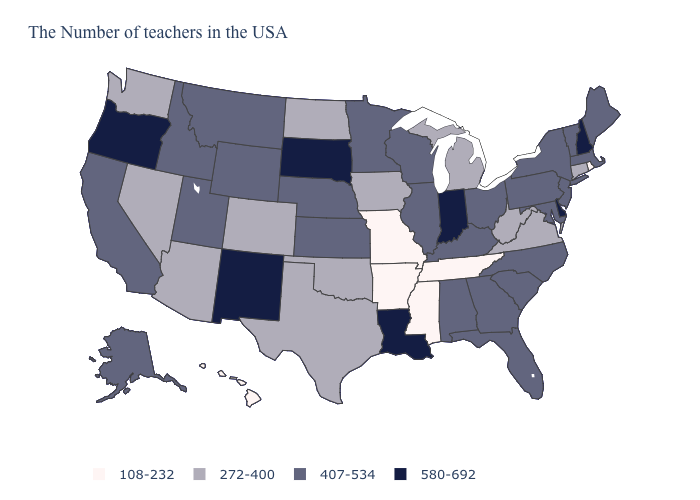Name the states that have a value in the range 272-400?
Quick response, please. Connecticut, Virginia, West Virginia, Michigan, Iowa, Oklahoma, Texas, North Dakota, Colorado, Arizona, Nevada, Washington. Which states have the lowest value in the West?
Answer briefly. Hawaii. Name the states that have a value in the range 272-400?
Concise answer only. Connecticut, Virginia, West Virginia, Michigan, Iowa, Oklahoma, Texas, North Dakota, Colorado, Arizona, Nevada, Washington. Which states have the highest value in the USA?
Answer briefly. New Hampshire, Delaware, Indiana, Louisiana, South Dakota, New Mexico, Oregon. Does Nevada have a lower value than Mississippi?
Short answer required. No. Name the states that have a value in the range 108-232?
Answer briefly. Rhode Island, Tennessee, Mississippi, Missouri, Arkansas, Hawaii. Does Oklahoma have a lower value than New Jersey?
Give a very brief answer. Yes. What is the value of Idaho?
Keep it brief. 407-534. Does Arkansas have the lowest value in the USA?
Be succinct. Yes. Name the states that have a value in the range 407-534?
Concise answer only. Maine, Massachusetts, Vermont, New York, New Jersey, Maryland, Pennsylvania, North Carolina, South Carolina, Ohio, Florida, Georgia, Kentucky, Alabama, Wisconsin, Illinois, Minnesota, Kansas, Nebraska, Wyoming, Utah, Montana, Idaho, California, Alaska. Among the states that border New Jersey , which have the lowest value?
Be succinct. New York, Pennsylvania. Does Maryland have the same value as Arizona?
Keep it brief. No. Which states have the lowest value in the USA?
Give a very brief answer. Rhode Island, Tennessee, Mississippi, Missouri, Arkansas, Hawaii. How many symbols are there in the legend?
Give a very brief answer. 4. 